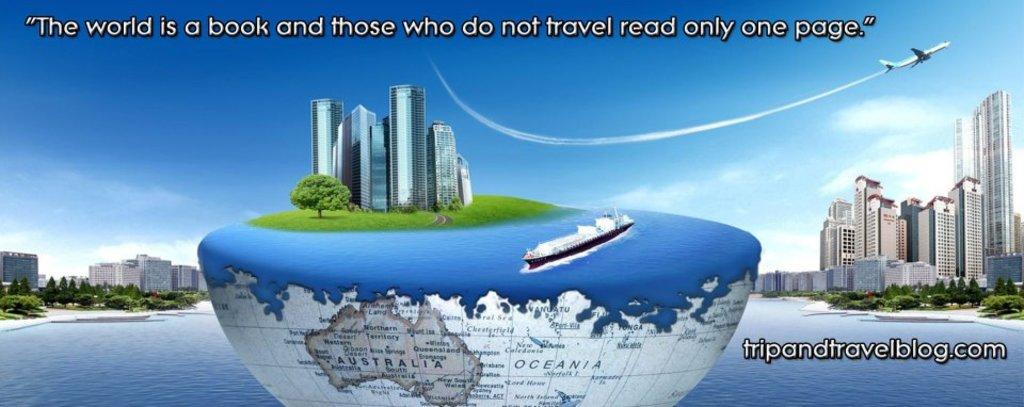What is the website displayed on this image?
Keep it short and to the point. Tripandtravelblog.com. Who said that quote?
Give a very brief answer. Unanswerable. 